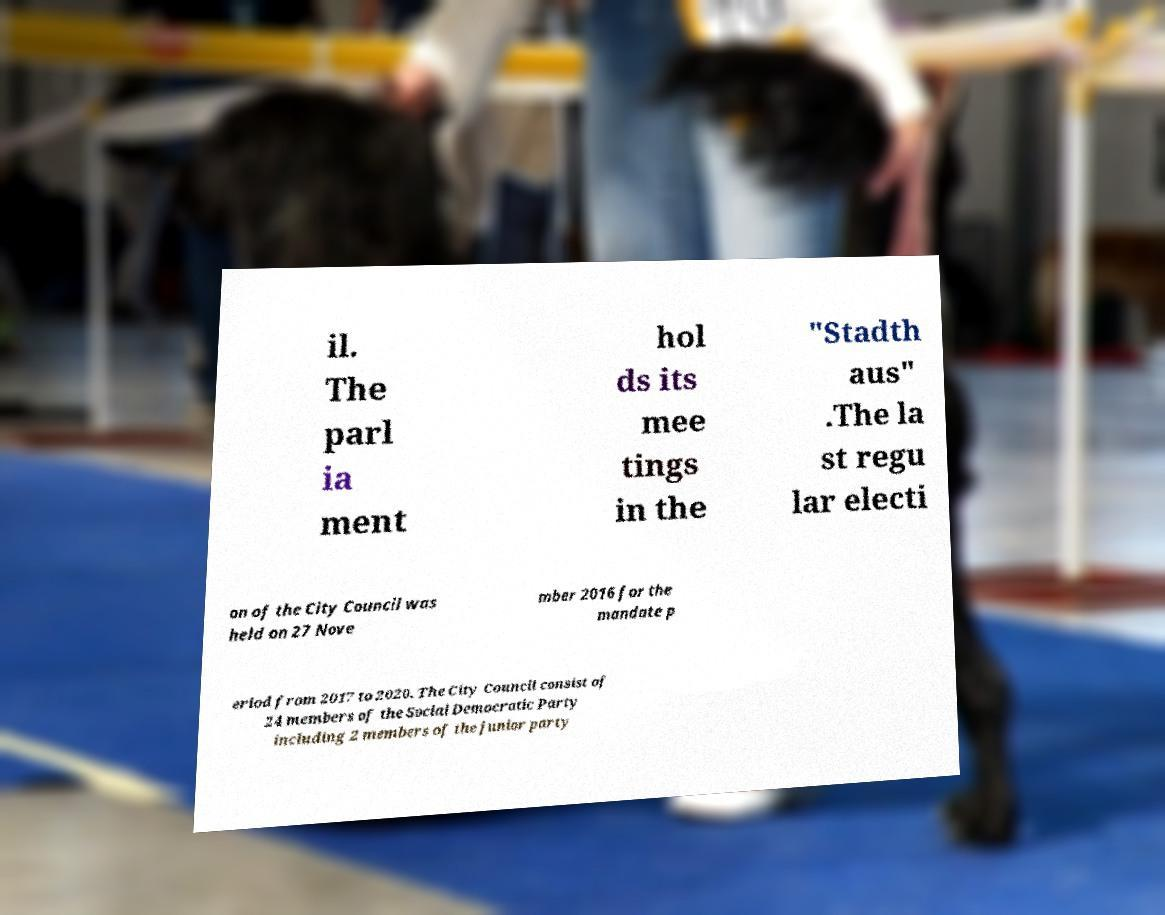Can you read and provide the text displayed in the image?This photo seems to have some interesting text. Can you extract and type it out for me? il. The parl ia ment hol ds its mee tings in the "Stadth aus" .The la st regu lar electi on of the City Council was held on 27 Nove mber 2016 for the mandate p eriod from 2017 to 2020. The City Council consist of 24 members of the Social Democratic Party including 2 members of the junior party 